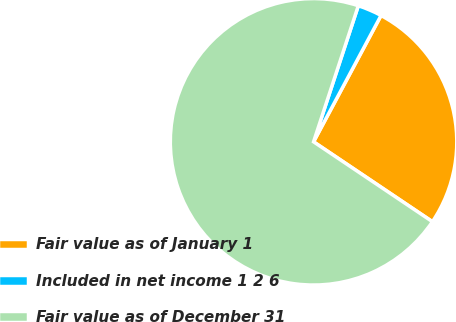Convert chart. <chart><loc_0><loc_0><loc_500><loc_500><pie_chart><fcel>Fair value as of January 1<fcel>Included in net income 1 2 6<fcel>Fair value as of December 31<nl><fcel>26.61%<fcel>2.75%<fcel>70.64%<nl></chart> 